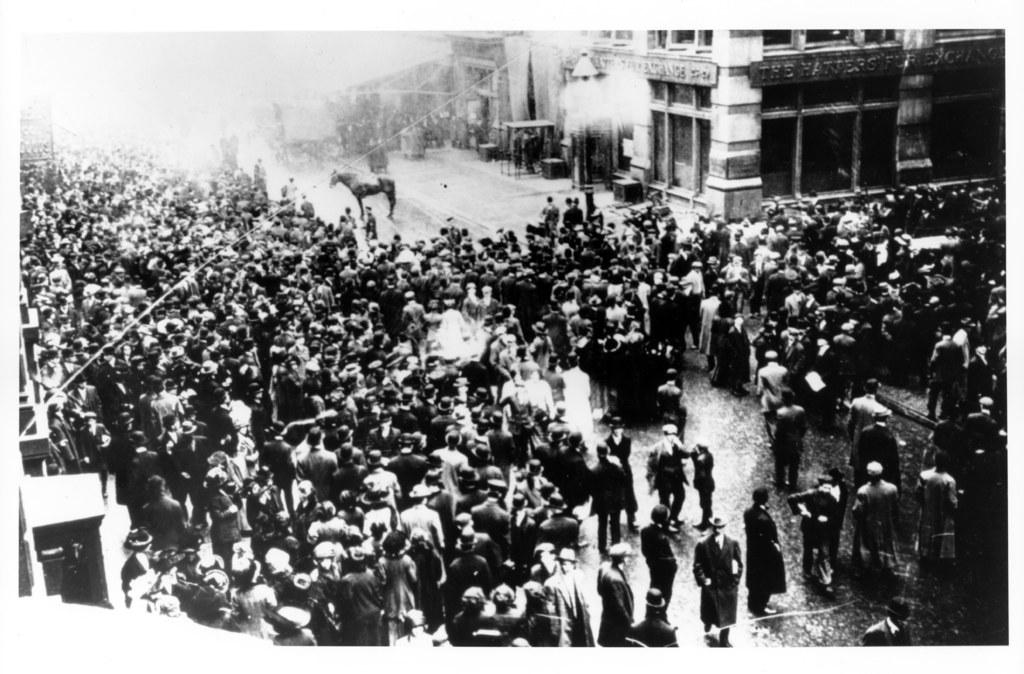What is the color scheme of the image? The image is black and white. What can be seen on the road in the image? There are many people standing on the road, as well as a horse. What type of structures are visible at the top of the image? There are buildings visible at the top of the image. What type of calculator can be seen in the hands of the people on the road? There is no calculator present in the image; it is a black and white image of people and a horse on the road, with buildings visible at the top. 